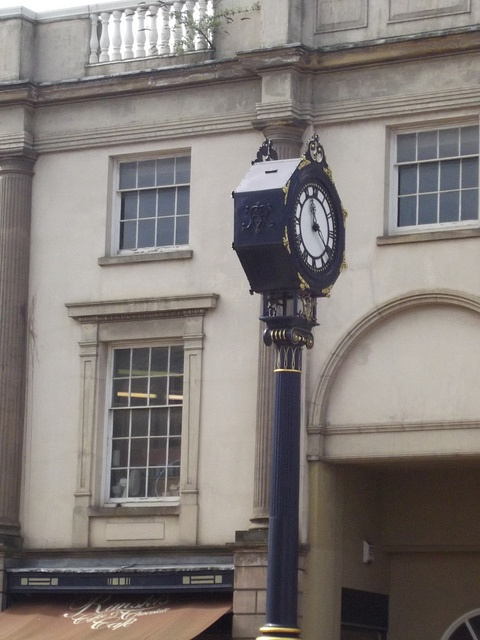Describe the objects in this image and their specific colors. I can see a clock in white, gray, darkgray, and black tones in this image. 